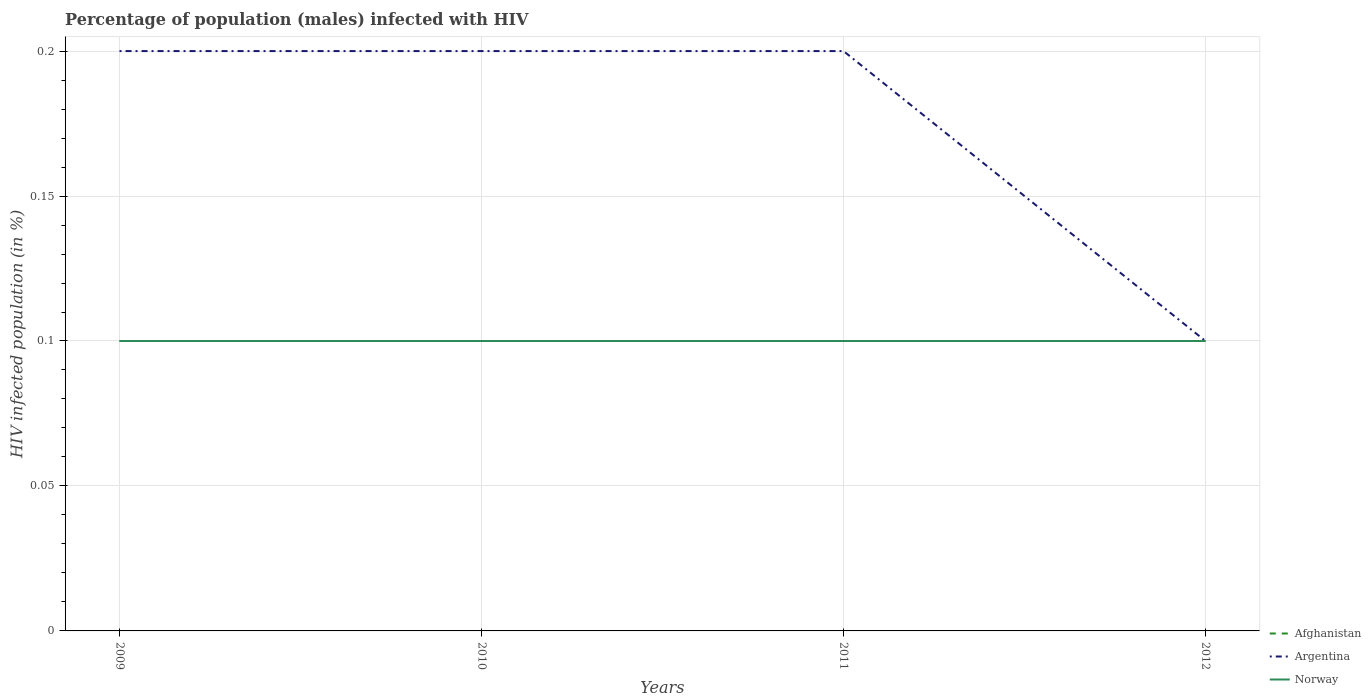Is the number of lines equal to the number of legend labels?
Ensure brevity in your answer.  Yes. Across all years, what is the maximum percentage of HIV infected male population in Afghanistan?
Your answer should be compact. 0.1. In which year was the percentage of HIV infected male population in Argentina maximum?
Give a very brief answer. 2012. What is the difference between the highest and the lowest percentage of HIV infected male population in Afghanistan?
Provide a short and direct response. 0. How many lines are there?
Provide a succinct answer. 3. How many years are there in the graph?
Offer a very short reply. 4. Are the values on the major ticks of Y-axis written in scientific E-notation?
Your answer should be compact. No. Does the graph contain any zero values?
Your response must be concise. No. Where does the legend appear in the graph?
Offer a very short reply. Bottom right. How many legend labels are there?
Provide a short and direct response. 3. How are the legend labels stacked?
Your answer should be compact. Vertical. What is the title of the graph?
Ensure brevity in your answer.  Percentage of population (males) infected with HIV. What is the label or title of the X-axis?
Offer a very short reply. Years. What is the label or title of the Y-axis?
Provide a succinct answer. HIV infected population (in %). What is the HIV infected population (in %) of Afghanistan in 2009?
Your response must be concise. 0.1. What is the HIV infected population (in %) of Afghanistan in 2010?
Offer a terse response. 0.1. What is the HIV infected population (in %) in Norway in 2010?
Offer a very short reply. 0.1. What is the HIV infected population (in %) of Afghanistan in 2011?
Your response must be concise. 0.1. What is the HIV infected population (in %) in Norway in 2011?
Offer a very short reply. 0.1. What is the HIV infected population (in %) in Argentina in 2012?
Provide a succinct answer. 0.1. Across all years, what is the minimum HIV infected population (in %) of Afghanistan?
Ensure brevity in your answer.  0.1. What is the total HIV infected population (in %) in Afghanistan in the graph?
Ensure brevity in your answer.  0.4. What is the difference between the HIV infected population (in %) of Norway in 2009 and that in 2010?
Your answer should be compact. 0. What is the difference between the HIV infected population (in %) in Norway in 2009 and that in 2011?
Provide a short and direct response. 0. What is the difference between the HIV infected population (in %) in Afghanistan in 2009 and that in 2012?
Ensure brevity in your answer.  0. What is the difference between the HIV infected population (in %) in Argentina in 2010 and that in 2011?
Provide a succinct answer. 0. What is the difference between the HIV infected population (in %) in Norway in 2010 and that in 2012?
Provide a short and direct response. 0. What is the difference between the HIV infected population (in %) in Afghanistan in 2011 and that in 2012?
Offer a very short reply. 0. What is the difference between the HIV infected population (in %) of Norway in 2011 and that in 2012?
Your response must be concise. 0. What is the difference between the HIV infected population (in %) of Argentina in 2009 and the HIV infected population (in %) of Norway in 2010?
Provide a short and direct response. 0.1. What is the difference between the HIV infected population (in %) in Afghanistan in 2009 and the HIV infected population (in %) in Norway in 2011?
Offer a terse response. 0. What is the difference between the HIV infected population (in %) of Afghanistan in 2010 and the HIV infected population (in %) of Argentina in 2011?
Give a very brief answer. -0.1. What is the difference between the HIV infected population (in %) in Argentina in 2010 and the HIV infected population (in %) in Norway in 2011?
Ensure brevity in your answer.  0.1. What is the difference between the HIV infected population (in %) of Afghanistan in 2010 and the HIV infected population (in %) of Argentina in 2012?
Your response must be concise. 0. What is the difference between the HIV infected population (in %) in Argentina in 2010 and the HIV infected population (in %) in Norway in 2012?
Provide a short and direct response. 0.1. What is the difference between the HIV infected population (in %) in Afghanistan in 2011 and the HIV infected population (in %) in Norway in 2012?
Give a very brief answer. 0. What is the difference between the HIV infected population (in %) of Argentina in 2011 and the HIV infected population (in %) of Norway in 2012?
Provide a short and direct response. 0.1. What is the average HIV infected population (in %) in Afghanistan per year?
Provide a succinct answer. 0.1. What is the average HIV infected population (in %) in Argentina per year?
Offer a terse response. 0.17. In the year 2009, what is the difference between the HIV infected population (in %) of Afghanistan and HIV infected population (in %) of Argentina?
Your response must be concise. -0.1. In the year 2009, what is the difference between the HIV infected population (in %) in Afghanistan and HIV infected population (in %) in Norway?
Provide a succinct answer. 0. In the year 2010, what is the difference between the HIV infected population (in %) in Argentina and HIV infected population (in %) in Norway?
Provide a succinct answer. 0.1. In the year 2011, what is the difference between the HIV infected population (in %) in Afghanistan and HIV infected population (in %) in Norway?
Provide a short and direct response. 0. In the year 2011, what is the difference between the HIV infected population (in %) of Argentina and HIV infected population (in %) of Norway?
Provide a succinct answer. 0.1. In the year 2012, what is the difference between the HIV infected population (in %) of Afghanistan and HIV infected population (in %) of Argentina?
Ensure brevity in your answer.  0. In the year 2012, what is the difference between the HIV infected population (in %) in Afghanistan and HIV infected population (in %) in Norway?
Ensure brevity in your answer.  0. What is the ratio of the HIV infected population (in %) in Argentina in 2009 to that in 2010?
Your response must be concise. 1. What is the ratio of the HIV infected population (in %) of Afghanistan in 2009 to that in 2011?
Offer a very short reply. 1. What is the ratio of the HIV infected population (in %) of Argentina in 2009 to that in 2012?
Offer a very short reply. 2. What is the ratio of the HIV infected population (in %) in Norway in 2009 to that in 2012?
Your answer should be very brief. 1. What is the ratio of the HIV infected population (in %) of Argentina in 2010 to that in 2011?
Provide a succinct answer. 1. What is the ratio of the HIV infected population (in %) in Norway in 2010 to that in 2011?
Your answer should be very brief. 1. What is the ratio of the HIV infected population (in %) in Argentina in 2010 to that in 2012?
Your response must be concise. 2. What is the ratio of the HIV infected population (in %) of Norway in 2010 to that in 2012?
Make the answer very short. 1. What is the ratio of the HIV infected population (in %) of Afghanistan in 2011 to that in 2012?
Your answer should be very brief. 1. What is the difference between the highest and the second highest HIV infected population (in %) in Argentina?
Give a very brief answer. 0. What is the difference between the highest and the second highest HIV infected population (in %) of Norway?
Your response must be concise. 0. What is the difference between the highest and the lowest HIV infected population (in %) in Argentina?
Offer a terse response. 0.1. 